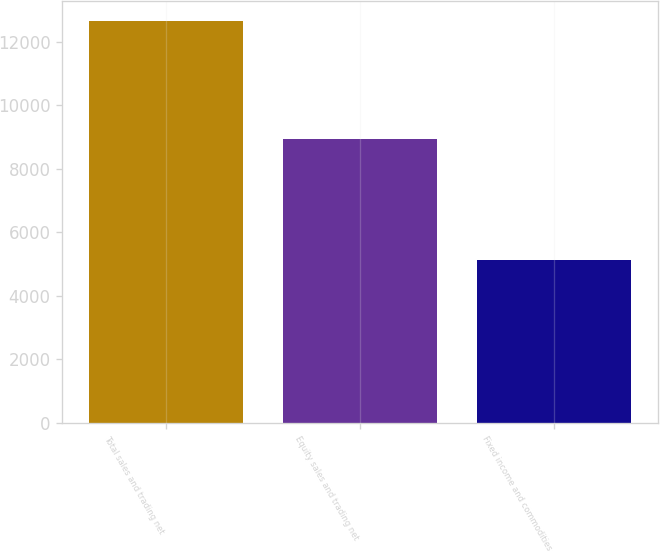Convert chart. <chart><loc_0><loc_0><loc_500><loc_500><bar_chart><fcel>Total sales and trading net<fcel>Equity sales and trading net<fcel>Fixed income and commodities<nl><fcel>12646.7<fcel>8939.7<fcel>5117.7<nl></chart> 